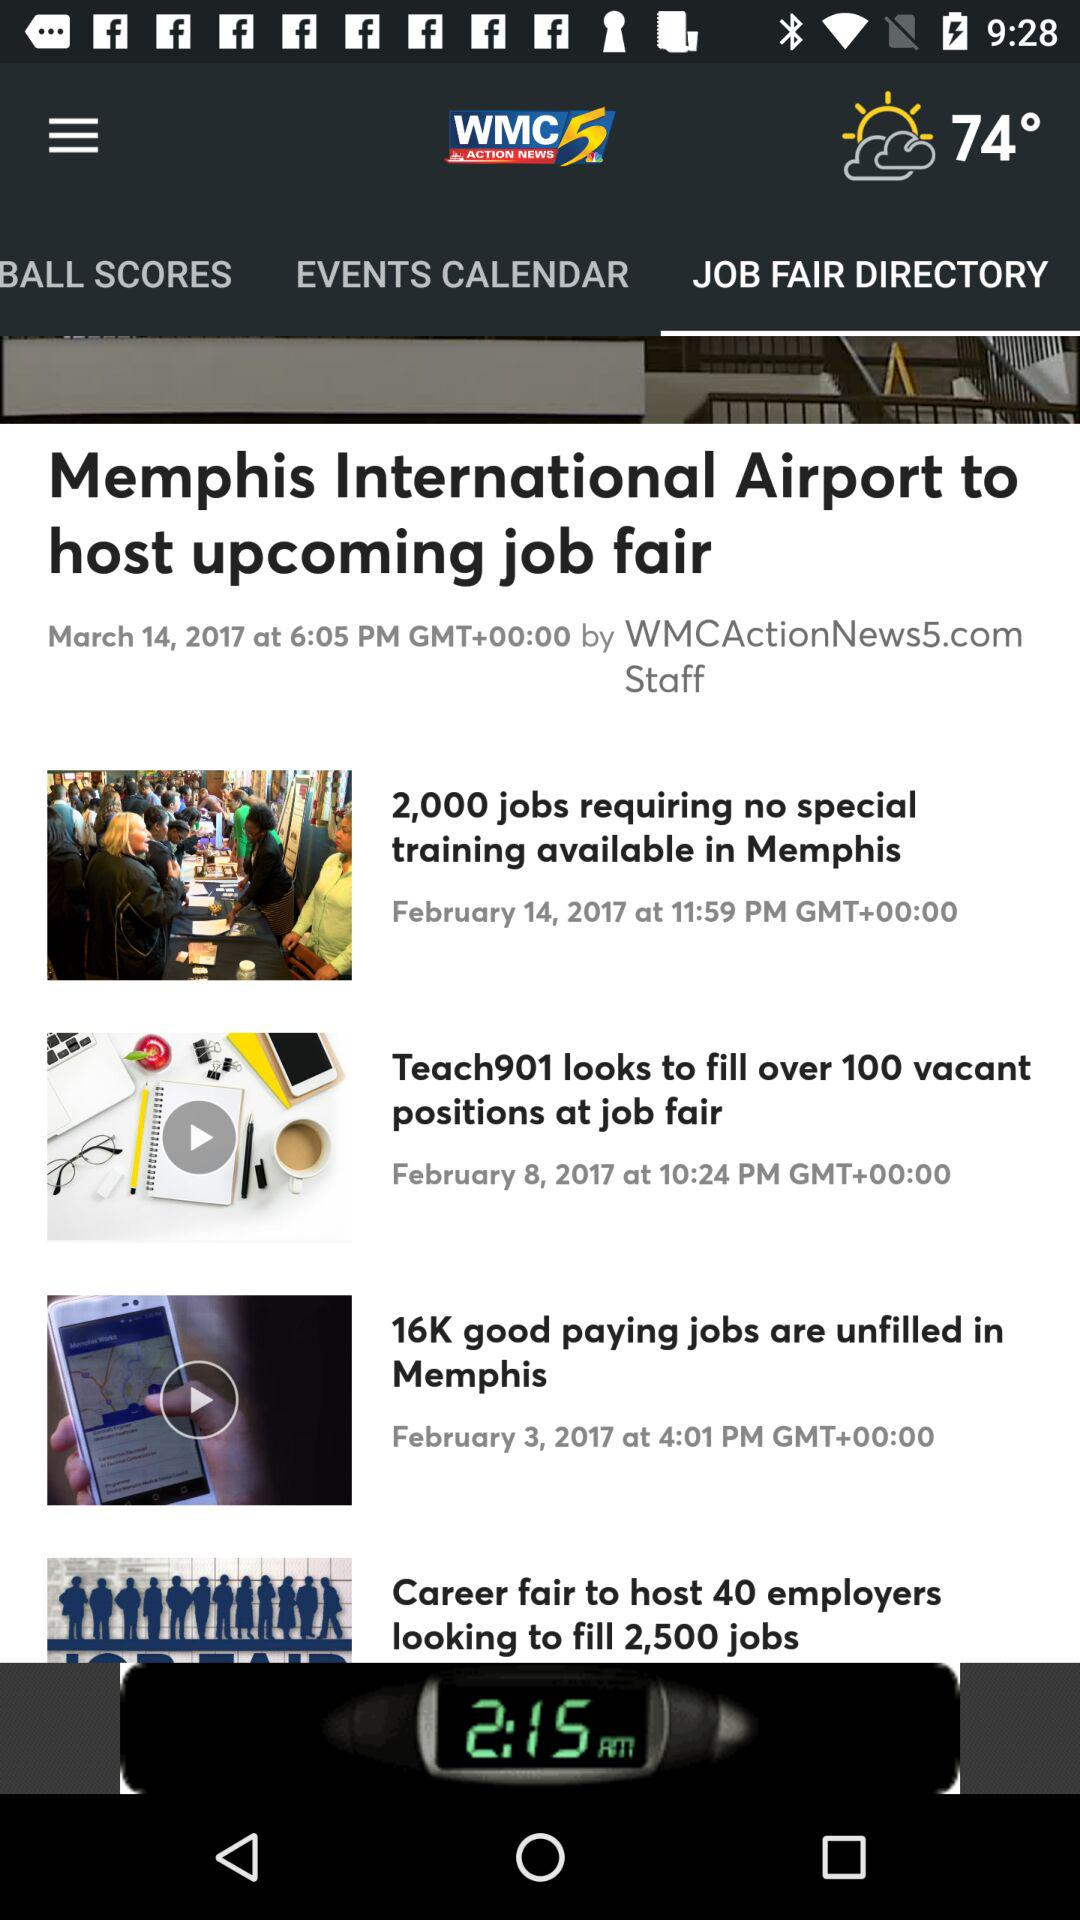What was the time of the post's update on February 14, 2017? The post was updated at 11:59 p.m. 